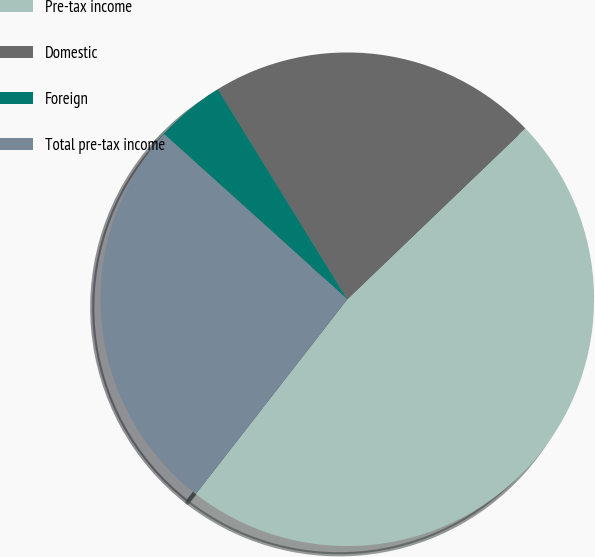Convert chart to OTSL. <chart><loc_0><loc_0><loc_500><loc_500><pie_chart><fcel>Pre-tax income<fcel>Domestic<fcel>Foreign<fcel>Total pre-tax income<nl><fcel>47.69%<fcel>21.62%<fcel>4.53%<fcel>26.15%<nl></chart> 